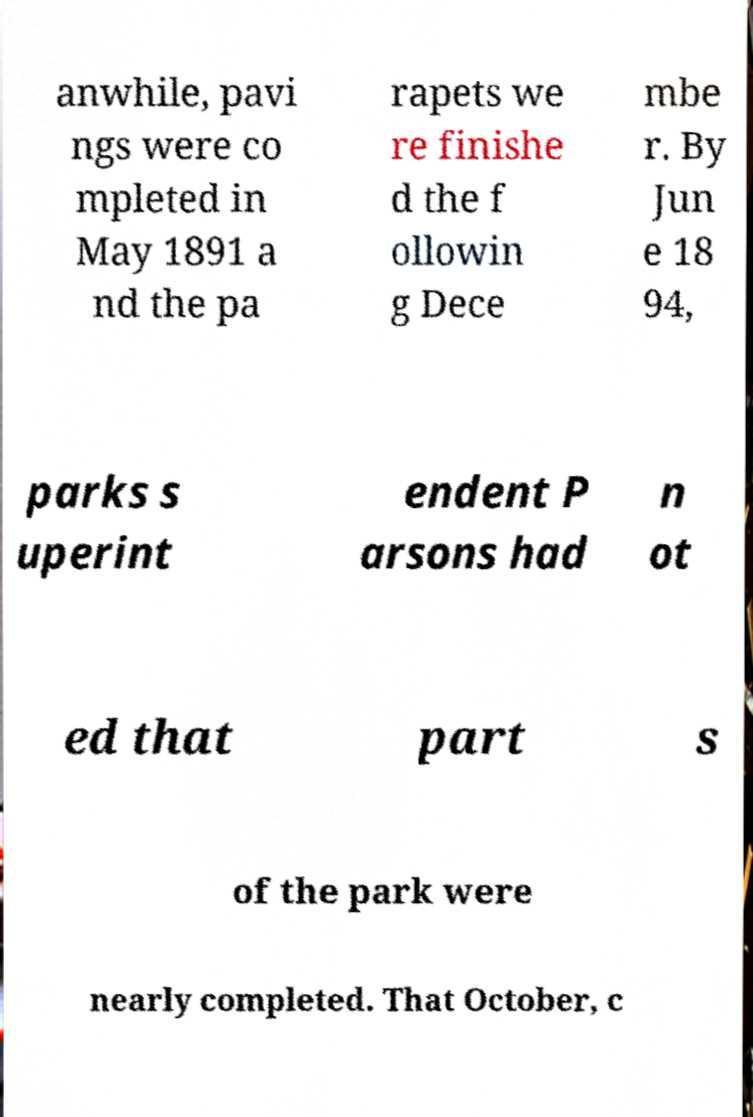What messages or text are displayed in this image? I need them in a readable, typed format. anwhile, pavi ngs were co mpleted in May 1891 a nd the pa rapets we re finishe d the f ollowin g Dece mbe r. By Jun e 18 94, parks s uperint endent P arsons had n ot ed that part s of the park were nearly completed. That October, c 